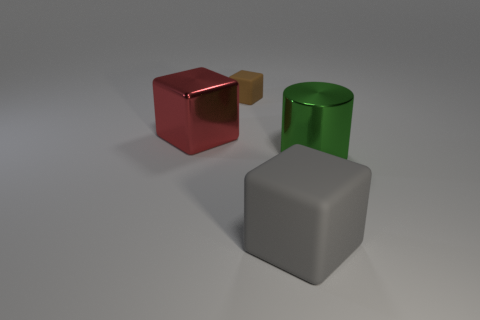Add 1 green metallic cylinders. How many objects exist? 5 Subtract all cylinders. How many objects are left? 3 Subtract 0 blue cubes. How many objects are left? 4 Subtract all big cylinders. Subtract all big gray rubber cubes. How many objects are left? 2 Add 1 red blocks. How many red blocks are left? 2 Add 1 small green metallic spheres. How many small green metallic spheres exist? 1 